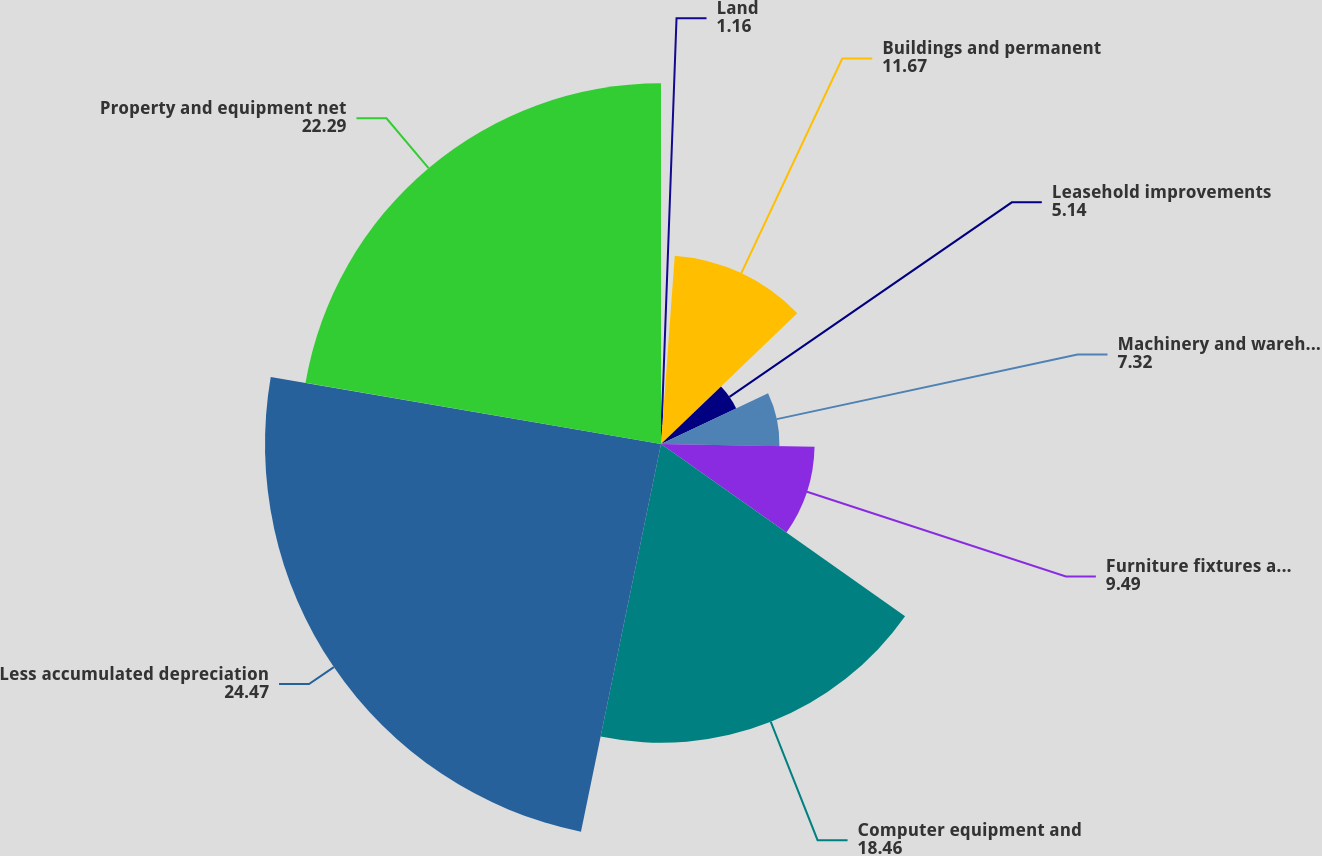Convert chart. <chart><loc_0><loc_0><loc_500><loc_500><pie_chart><fcel>Land<fcel>Buildings and permanent<fcel>Leasehold improvements<fcel>Machinery and warehouse<fcel>Furniture fixtures and other<fcel>Computer equipment and<fcel>Less accumulated depreciation<fcel>Property and equipment net<nl><fcel>1.16%<fcel>11.67%<fcel>5.14%<fcel>7.32%<fcel>9.49%<fcel>18.46%<fcel>24.47%<fcel>22.29%<nl></chart> 